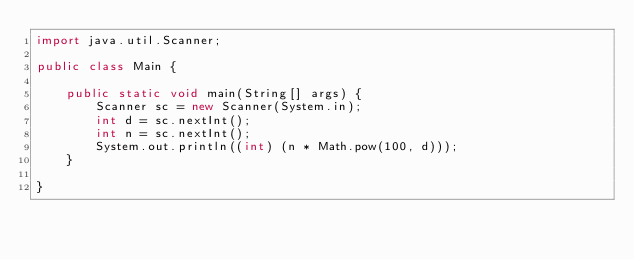<code> <loc_0><loc_0><loc_500><loc_500><_Java_>import java.util.Scanner;

public class Main {

    public static void main(String[] args) {
        Scanner sc = new Scanner(System.in);
        int d = sc.nextInt();
        int n = sc.nextInt();
        System.out.println((int) (n * Math.pow(100, d)));
    }

}
</code> 